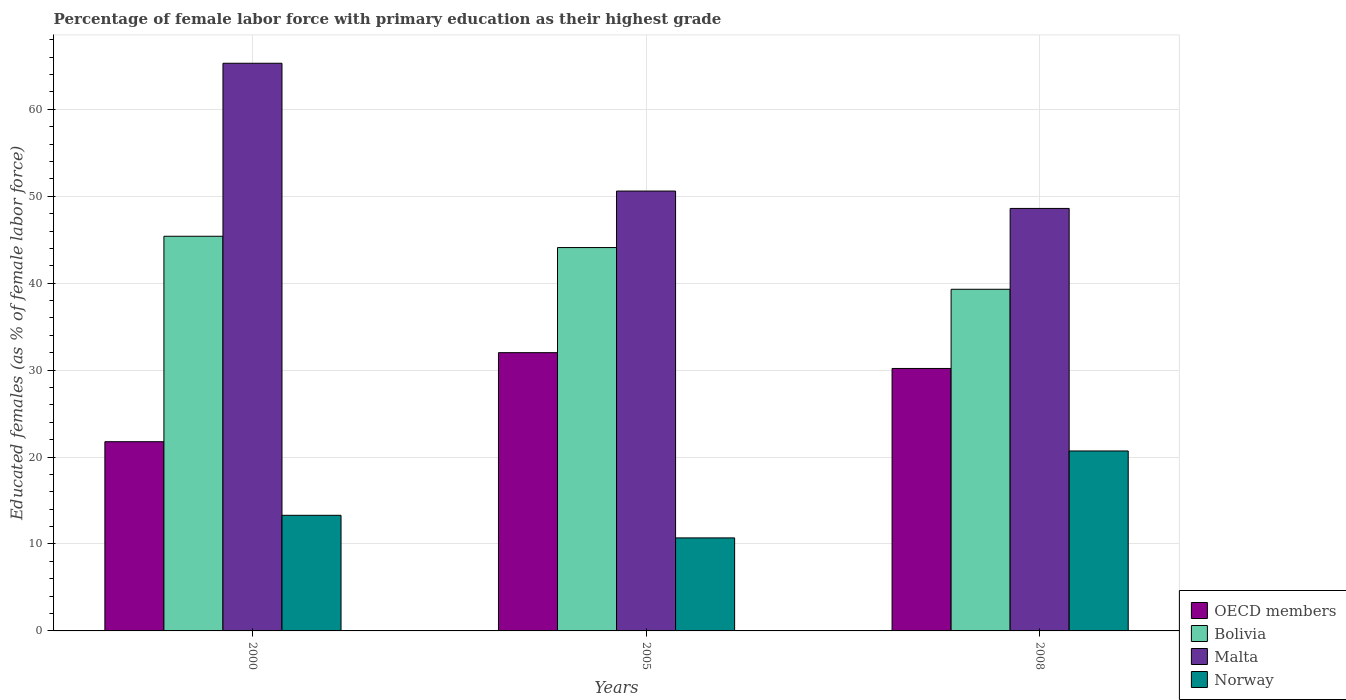How many different coloured bars are there?
Ensure brevity in your answer.  4. Are the number of bars per tick equal to the number of legend labels?
Your answer should be compact. Yes. What is the percentage of female labor force with primary education in Malta in 2000?
Your answer should be compact. 65.3. Across all years, what is the maximum percentage of female labor force with primary education in Bolivia?
Offer a terse response. 45.4. Across all years, what is the minimum percentage of female labor force with primary education in Bolivia?
Your response must be concise. 39.3. In which year was the percentage of female labor force with primary education in Malta maximum?
Offer a terse response. 2000. What is the total percentage of female labor force with primary education in Bolivia in the graph?
Your response must be concise. 128.8. What is the difference between the percentage of female labor force with primary education in OECD members in 2005 and that in 2008?
Offer a very short reply. 1.82. What is the difference between the percentage of female labor force with primary education in Bolivia in 2008 and the percentage of female labor force with primary education in Malta in 2000?
Offer a very short reply. -26. What is the average percentage of female labor force with primary education in Bolivia per year?
Ensure brevity in your answer.  42.93. In the year 2000, what is the difference between the percentage of female labor force with primary education in Malta and percentage of female labor force with primary education in Norway?
Your response must be concise. 52. What is the ratio of the percentage of female labor force with primary education in OECD members in 2005 to that in 2008?
Provide a short and direct response. 1.06. What is the difference between the highest and the second highest percentage of female labor force with primary education in OECD members?
Provide a short and direct response. 1.82. What is the difference between the highest and the lowest percentage of female labor force with primary education in Bolivia?
Keep it short and to the point. 6.1. What does the 3rd bar from the left in 2000 represents?
Keep it short and to the point. Malta. What does the 1st bar from the right in 2000 represents?
Offer a very short reply. Norway. Is it the case that in every year, the sum of the percentage of female labor force with primary education in Malta and percentage of female labor force with primary education in Bolivia is greater than the percentage of female labor force with primary education in OECD members?
Provide a succinct answer. Yes. Are all the bars in the graph horizontal?
Provide a succinct answer. No. How many years are there in the graph?
Make the answer very short. 3. Are the values on the major ticks of Y-axis written in scientific E-notation?
Your answer should be very brief. No. Where does the legend appear in the graph?
Your answer should be very brief. Bottom right. How are the legend labels stacked?
Your answer should be very brief. Vertical. What is the title of the graph?
Your answer should be very brief. Percentage of female labor force with primary education as their highest grade. Does "East Asia (developing only)" appear as one of the legend labels in the graph?
Provide a short and direct response. No. What is the label or title of the Y-axis?
Offer a terse response. Educated females (as % of female labor force). What is the Educated females (as % of female labor force) of OECD members in 2000?
Your answer should be compact. 21.77. What is the Educated females (as % of female labor force) of Bolivia in 2000?
Ensure brevity in your answer.  45.4. What is the Educated females (as % of female labor force) of Malta in 2000?
Offer a very short reply. 65.3. What is the Educated females (as % of female labor force) in Norway in 2000?
Provide a short and direct response. 13.3. What is the Educated females (as % of female labor force) of OECD members in 2005?
Provide a short and direct response. 32.01. What is the Educated females (as % of female labor force) of Bolivia in 2005?
Give a very brief answer. 44.1. What is the Educated females (as % of female labor force) in Malta in 2005?
Your response must be concise. 50.6. What is the Educated females (as % of female labor force) of Norway in 2005?
Make the answer very short. 10.7. What is the Educated females (as % of female labor force) of OECD members in 2008?
Provide a short and direct response. 30.19. What is the Educated females (as % of female labor force) of Bolivia in 2008?
Your answer should be very brief. 39.3. What is the Educated females (as % of female labor force) in Malta in 2008?
Your response must be concise. 48.6. What is the Educated females (as % of female labor force) of Norway in 2008?
Offer a terse response. 20.7. Across all years, what is the maximum Educated females (as % of female labor force) of OECD members?
Give a very brief answer. 32.01. Across all years, what is the maximum Educated females (as % of female labor force) in Bolivia?
Your response must be concise. 45.4. Across all years, what is the maximum Educated females (as % of female labor force) in Malta?
Provide a succinct answer. 65.3. Across all years, what is the maximum Educated females (as % of female labor force) of Norway?
Your response must be concise. 20.7. Across all years, what is the minimum Educated females (as % of female labor force) of OECD members?
Give a very brief answer. 21.77. Across all years, what is the minimum Educated females (as % of female labor force) in Bolivia?
Make the answer very short. 39.3. Across all years, what is the minimum Educated females (as % of female labor force) in Malta?
Give a very brief answer. 48.6. Across all years, what is the minimum Educated females (as % of female labor force) in Norway?
Offer a terse response. 10.7. What is the total Educated females (as % of female labor force) in OECD members in the graph?
Ensure brevity in your answer.  83.97. What is the total Educated females (as % of female labor force) of Bolivia in the graph?
Keep it short and to the point. 128.8. What is the total Educated females (as % of female labor force) in Malta in the graph?
Your answer should be compact. 164.5. What is the total Educated females (as % of female labor force) of Norway in the graph?
Your response must be concise. 44.7. What is the difference between the Educated females (as % of female labor force) in OECD members in 2000 and that in 2005?
Your response must be concise. -10.24. What is the difference between the Educated females (as % of female labor force) of OECD members in 2000 and that in 2008?
Make the answer very short. -8.43. What is the difference between the Educated females (as % of female labor force) of Bolivia in 2000 and that in 2008?
Provide a short and direct response. 6.1. What is the difference between the Educated females (as % of female labor force) in Norway in 2000 and that in 2008?
Offer a very short reply. -7.4. What is the difference between the Educated females (as % of female labor force) of OECD members in 2005 and that in 2008?
Keep it short and to the point. 1.82. What is the difference between the Educated females (as % of female labor force) of Bolivia in 2005 and that in 2008?
Provide a short and direct response. 4.8. What is the difference between the Educated females (as % of female labor force) of Malta in 2005 and that in 2008?
Offer a very short reply. 2. What is the difference between the Educated females (as % of female labor force) of OECD members in 2000 and the Educated females (as % of female labor force) of Bolivia in 2005?
Provide a short and direct response. -22.33. What is the difference between the Educated females (as % of female labor force) of OECD members in 2000 and the Educated females (as % of female labor force) of Malta in 2005?
Your response must be concise. -28.83. What is the difference between the Educated females (as % of female labor force) of OECD members in 2000 and the Educated females (as % of female labor force) of Norway in 2005?
Your response must be concise. 11.07. What is the difference between the Educated females (as % of female labor force) in Bolivia in 2000 and the Educated females (as % of female labor force) in Norway in 2005?
Keep it short and to the point. 34.7. What is the difference between the Educated females (as % of female labor force) in Malta in 2000 and the Educated females (as % of female labor force) in Norway in 2005?
Offer a very short reply. 54.6. What is the difference between the Educated females (as % of female labor force) in OECD members in 2000 and the Educated females (as % of female labor force) in Bolivia in 2008?
Provide a succinct answer. -17.53. What is the difference between the Educated females (as % of female labor force) in OECD members in 2000 and the Educated females (as % of female labor force) in Malta in 2008?
Make the answer very short. -26.83. What is the difference between the Educated females (as % of female labor force) in OECD members in 2000 and the Educated females (as % of female labor force) in Norway in 2008?
Give a very brief answer. 1.07. What is the difference between the Educated females (as % of female labor force) of Bolivia in 2000 and the Educated females (as % of female labor force) of Malta in 2008?
Offer a very short reply. -3.2. What is the difference between the Educated females (as % of female labor force) in Bolivia in 2000 and the Educated females (as % of female labor force) in Norway in 2008?
Your response must be concise. 24.7. What is the difference between the Educated females (as % of female labor force) of Malta in 2000 and the Educated females (as % of female labor force) of Norway in 2008?
Provide a short and direct response. 44.6. What is the difference between the Educated females (as % of female labor force) of OECD members in 2005 and the Educated females (as % of female labor force) of Bolivia in 2008?
Give a very brief answer. -7.29. What is the difference between the Educated females (as % of female labor force) of OECD members in 2005 and the Educated females (as % of female labor force) of Malta in 2008?
Offer a very short reply. -16.59. What is the difference between the Educated females (as % of female labor force) in OECD members in 2005 and the Educated females (as % of female labor force) in Norway in 2008?
Provide a succinct answer. 11.31. What is the difference between the Educated females (as % of female labor force) in Bolivia in 2005 and the Educated females (as % of female labor force) in Malta in 2008?
Offer a very short reply. -4.5. What is the difference between the Educated females (as % of female labor force) in Bolivia in 2005 and the Educated females (as % of female labor force) in Norway in 2008?
Ensure brevity in your answer.  23.4. What is the difference between the Educated females (as % of female labor force) of Malta in 2005 and the Educated females (as % of female labor force) of Norway in 2008?
Your answer should be very brief. 29.9. What is the average Educated females (as % of female labor force) of OECD members per year?
Keep it short and to the point. 27.99. What is the average Educated females (as % of female labor force) of Bolivia per year?
Ensure brevity in your answer.  42.93. What is the average Educated females (as % of female labor force) in Malta per year?
Your answer should be compact. 54.83. What is the average Educated females (as % of female labor force) in Norway per year?
Give a very brief answer. 14.9. In the year 2000, what is the difference between the Educated females (as % of female labor force) of OECD members and Educated females (as % of female labor force) of Bolivia?
Your answer should be very brief. -23.63. In the year 2000, what is the difference between the Educated females (as % of female labor force) of OECD members and Educated females (as % of female labor force) of Malta?
Make the answer very short. -43.53. In the year 2000, what is the difference between the Educated females (as % of female labor force) of OECD members and Educated females (as % of female labor force) of Norway?
Offer a terse response. 8.47. In the year 2000, what is the difference between the Educated females (as % of female labor force) of Bolivia and Educated females (as % of female labor force) of Malta?
Provide a short and direct response. -19.9. In the year 2000, what is the difference between the Educated females (as % of female labor force) in Bolivia and Educated females (as % of female labor force) in Norway?
Ensure brevity in your answer.  32.1. In the year 2005, what is the difference between the Educated females (as % of female labor force) of OECD members and Educated females (as % of female labor force) of Bolivia?
Provide a succinct answer. -12.09. In the year 2005, what is the difference between the Educated females (as % of female labor force) in OECD members and Educated females (as % of female labor force) in Malta?
Keep it short and to the point. -18.59. In the year 2005, what is the difference between the Educated females (as % of female labor force) in OECD members and Educated females (as % of female labor force) in Norway?
Provide a short and direct response. 21.31. In the year 2005, what is the difference between the Educated females (as % of female labor force) of Bolivia and Educated females (as % of female labor force) of Malta?
Provide a short and direct response. -6.5. In the year 2005, what is the difference between the Educated females (as % of female labor force) of Bolivia and Educated females (as % of female labor force) of Norway?
Offer a very short reply. 33.4. In the year 2005, what is the difference between the Educated females (as % of female labor force) in Malta and Educated females (as % of female labor force) in Norway?
Ensure brevity in your answer.  39.9. In the year 2008, what is the difference between the Educated females (as % of female labor force) of OECD members and Educated females (as % of female labor force) of Bolivia?
Offer a terse response. -9.11. In the year 2008, what is the difference between the Educated females (as % of female labor force) of OECD members and Educated females (as % of female labor force) of Malta?
Provide a short and direct response. -18.41. In the year 2008, what is the difference between the Educated females (as % of female labor force) of OECD members and Educated females (as % of female labor force) of Norway?
Offer a very short reply. 9.49. In the year 2008, what is the difference between the Educated females (as % of female labor force) in Bolivia and Educated females (as % of female labor force) in Malta?
Your answer should be very brief. -9.3. In the year 2008, what is the difference between the Educated females (as % of female labor force) in Bolivia and Educated females (as % of female labor force) in Norway?
Make the answer very short. 18.6. In the year 2008, what is the difference between the Educated females (as % of female labor force) in Malta and Educated females (as % of female labor force) in Norway?
Give a very brief answer. 27.9. What is the ratio of the Educated females (as % of female labor force) of OECD members in 2000 to that in 2005?
Your answer should be very brief. 0.68. What is the ratio of the Educated females (as % of female labor force) of Bolivia in 2000 to that in 2005?
Offer a very short reply. 1.03. What is the ratio of the Educated females (as % of female labor force) in Malta in 2000 to that in 2005?
Give a very brief answer. 1.29. What is the ratio of the Educated females (as % of female labor force) of Norway in 2000 to that in 2005?
Keep it short and to the point. 1.24. What is the ratio of the Educated females (as % of female labor force) of OECD members in 2000 to that in 2008?
Give a very brief answer. 0.72. What is the ratio of the Educated females (as % of female labor force) of Bolivia in 2000 to that in 2008?
Offer a terse response. 1.16. What is the ratio of the Educated females (as % of female labor force) of Malta in 2000 to that in 2008?
Your response must be concise. 1.34. What is the ratio of the Educated females (as % of female labor force) of Norway in 2000 to that in 2008?
Provide a succinct answer. 0.64. What is the ratio of the Educated females (as % of female labor force) of OECD members in 2005 to that in 2008?
Make the answer very short. 1.06. What is the ratio of the Educated females (as % of female labor force) in Bolivia in 2005 to that in 2008?
Your answer should be compact. 1.12. What is the ratio of the Educated females (as % of female labor force) of Malta in 2005 to that in 2008?
Your answer should be very brief. 1.04. What is the ratio of the Educated females (as % of female labor force) of Norway in 2005 to that in 2008?
Your answer should be compact. 0.52. What is the difference between the highest and the second highest Educated females (as % of female labor force) in OECD members?
Provide a succinct answer. 1.82. What is the difference between the highest and the second highest Educated females (as % of female labor force) in Norway?
Your answer should be very brief. 7.4. What is the difference between the highest and the lowest Educated females (as % of female labor force) of OECD members?
Offer a terse response. 10.24. What is the difference between the highest and the lowest Educated females (as % of female labor force) of Norway?
Keep it short and to the point. 10. 